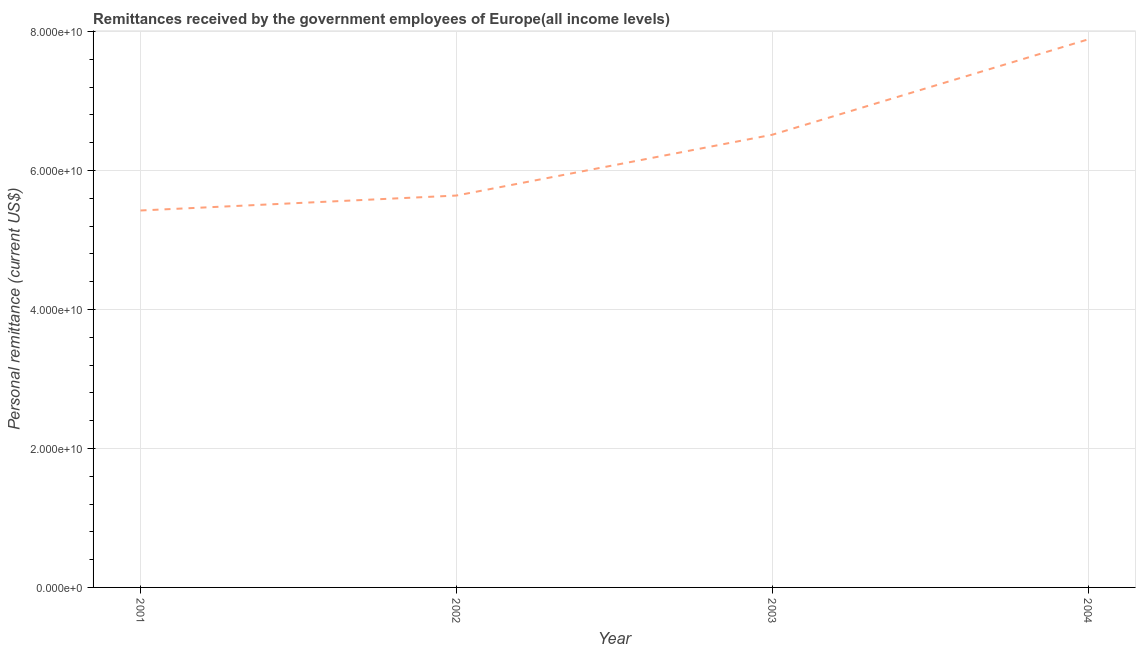What is the personal remittances in 2001?
Keep it short and to the point. 5.42e+1. Across all years, what is the maximum personal remittances?
Ensure brevity in your answer.  7.89e+1. Across all years, what is the minimum personal remittances?
Give a very brief answer. 5.42e+1. In which year was the personal remittances maximum?
Provide a short and direct response. 2004. What is the sum of the personal remittances?
Your answer should be compact. 2.55e+11. What is the difference between the personal remittances in 2001 and 2002?
Make the answer very short. -2.15e+09. What is the average personal remittances per year?
Offer a very short reply. 6.37e+1. What is the median personal remittances?
Provide a short and direct response. 6.08e+1. In how many years, is the personal remittances greater than 44000000000 US$?
Ensure brevity in your answer.  4. What is the ratio of the personal remittances in 2002 to that in 2004?
Offer a terse response. 0.72. Is the personal remittances in 2002 less than that in 2003?
Make the answer very short. Yes. What is the difference between the highest and the second highest personal remittances?
Make the answer very short. 1.37e+1. Is the sum of the personal remittances in 2002 and 2004 greater than the maximum personal remittances across all years?
Provide a short and direct response. Yes. What is the difference between the highest and the lowest personal remittances?
Make the answer very short. 2.46e+1. How many years are there in the graph?
Provide a short and direct response. 4. Are the values on the major ticks of Y-axis written in scientific E-notation?
Ensure brevity in your answer.  Yes. Does the graph contain any zero values?
Keep it short and to the point. No. What is the title of the graph?
Offer a terse response. Remittances received by the government employees of Europe(all income levels). What is the label or title of the X-axis?
Keep it short and to the point. Year. What is the label or title of the Y-axis?
Ensure brevity in your answer.  Personal remittance (current US$). What is the Personal remittance (current US$) in 2001?
Your answer should be very brief. 5.42e+1. What is the Personal remittance (current US$) of 2002?
Offer a terse response. 5.64e+1. What is the Personal remittance (current US$) in 2003?
Offer a terse response. 6.51e+1. What is the Personal remittance (current US$) of 2004?
Provide a short and direct response. 7.89e+1. What is the difference between the Personal remittance (current US$) in 2001 and 2002?
Ensure brevity in your answer.  -2.15e+09. What is the difference between the Personal remittance (current US$) in 2001 and 2003?
Give a very brief answer. -1.09e+1. What is the difference between the Personal remittance (current US$) in 2001 and 2004?
Make the answer very short. -2.46e+1. What is the difference between the Personal remittance (current US$) in 2002 and 2003?
Keep it short and to the point. -8.75e+09. What is the difference between the Personal remittance (current US$) in 2002 and 2004?
Offer a very short reply. -2.25e+1. What is the difference between the Personal remittance (current US$) in 2003 and 2004?
Your response must be concise. -1.37e+1. What is the ratio of the Personal remittance (current US$) in 2001 to that in 2003?
Give a very brief answer. 0.83. What is the ratio of the Personal remittance (current US$) in 2001 to that in 2004?
Provide a short and direct response. 0.69. What is the ratio of the Personal remittance (current US$) in 2002 to that in 2003?
Provide a short and direct response. 0.87. What is the ratio of the Personal remittance (current US$) in 2002 to that in 2004?
Keep it short and to the point. 0.71. What is the ratio of the Personal remittance (current US$) in 2003 to that in 2004?
Your answer should be very brief. 0.83. 